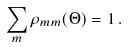<formula> <loc_0><loc_0><loc_500><loc_500>\sum _ { m } \rho _ { m m } ( \Theta ) = 1 \, .</formula> 